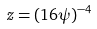<formula> <loc_0><loc_0><loc_500><loc_500>z = ( 1 6 \psi ) ^ { - 4 }</formula> 